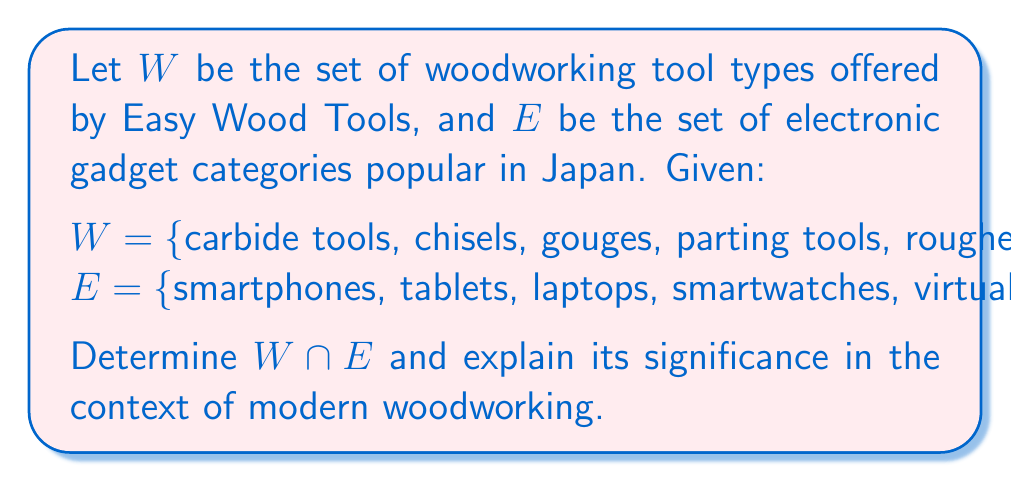Show me your answer to this math problem. To solve this problem, we need to understand the concept of set intersection and apply it to the given sets.

1. Set intersection:
   The intersection of two sets A and B, denoted as $A \cap B$, is the set of all elements that are common to both A and B.

2. Analyzing the given sets:
   $W = \{\text{carbide tools, chisels, gouges, parting tools, roughers}\}$
   $E = \{\text{smartphones, tablets, laptops, smartwatches, virtual reality headsets}\}$

3. Comparing elements:
   We need to identify any elements that appear in both sets. However, upon inspection, we can see that there are no common elements between $W$ and $E$.

4. Determining the intersection:
   Since there are no common elements, the intersection of $W$ and $E$ is an empty set, denoted as $\emptyset$ or $\{\}$.

5. Significance in modern woodworking:
   The empty intersection highlights the traditional nature of woodworking tools offered by Easy Wood Tools, which do not directly overlap with electronic gadgets. However, this doesn't mean that electronic devices are not used in modern woodworking. Many woodworkers use smartphones or tablets for design inspiration, project planning, or even as digital measurement tools. The empty intersection suggests an opportunity for innovation in combining traditional woodworking tools with electronic technology.
Answer: $W \cap E = \emptyset$ 